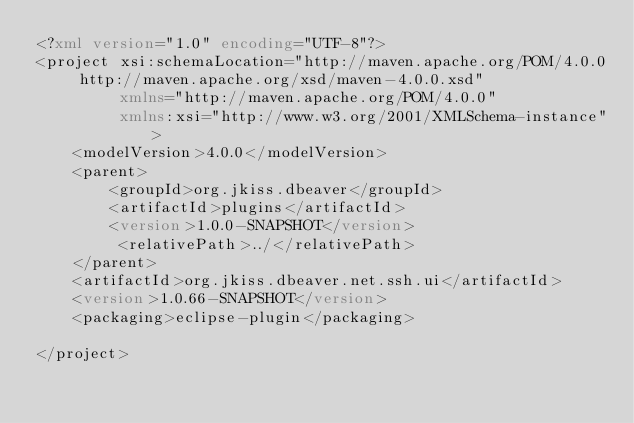Convert code to text. <code><loc_0><loc_0><loc_500><loc_500><_XML_><?xml version="1.0" encoding="UTF-8"?>
<project xsi:schemaLocation="http://maven.apache.org/POM/4.0.0 http://maven.apache.org/xsd/maven-4.0.0.xsd"
         xmlns="http://maven.apache.org/POM/4.0.0"
         xmlns:xsi="http://www.w3.org/2001/XMLSchema-instance">
    <modelVersion>4.0.0</modelVersion>
    <parent>
        <groupId>org.jkiss.dbeaver</groupId>
        <artifactId>plugins</artifactId>
        <version>1.0.0-SNAPSHOT</version>
         <relativePath>../</relativePath>
    </parent>
    <artifactId>org.jkiss.dbeaver.net.ssh.ui</artifactId>
    <version>1.0.66-SNAPSHOT</version>
    <packaging>eclipse-plugin</packaging>

</project>
</code> 